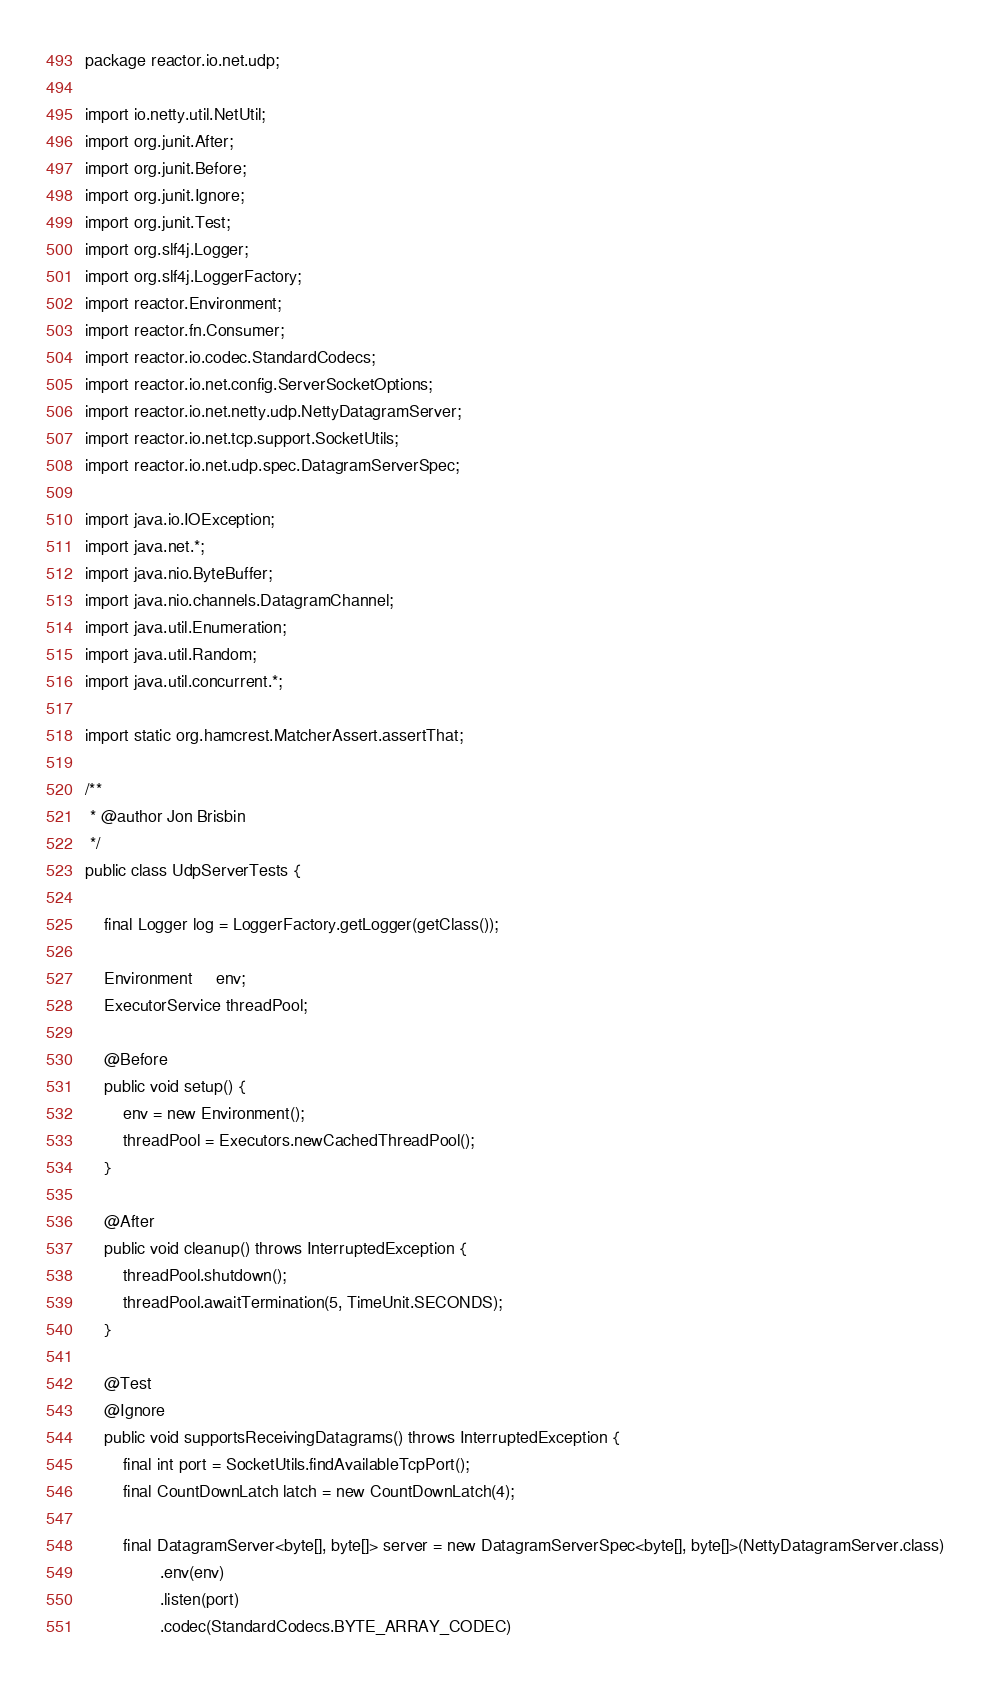Convert code to text. <code><loc_0><loc_0><loc_500><loc_500><_Java_>package reactor.io.net.udp;

import io.netty.util.NetUtil;
import org.junit.After;
import org.junit.Before;
import org.junit.Ignore;
import org.junit.Test;
import org.slf4j.Logger;
import org.slf4j.LoggerFactory;
import reactor.Environment;
import reactor.fn.Consumer;
import reactor.io.codec.StandardCodecs;
import reactor.io.net.config.ServerSocketOptions;
import reactor.io.net.netty.udp.NettyDatagramServer;
import reactor.io.net.tcp.support.SocketUtils;
import reactor.io.net.udp.spec.DatagramServerSpec;

import java.io.IOException;
import java.net.*;
import java.nio.ByteBuffer;
import java.nio.channels.DatagramChannel;
import java.util.Enumeration;
import java.util.Random;
import java.util.concurrent.*;

import static org.hamcrest.MatcherAssert.assertThat;

/**
 * @author Jon Brisbin
 */
public class UdpServerTests {

	final Logger log = LoggerFactory.getLogger(getClass());

	Environment     env;
	ExecutorService threadPool;

	@Before
	public void setup() {
		env = new Environment();
		threadPool = Executors.newCachedThreadPool();
	}

	@After
	public void cleanup() throws InterruptedException {
		threadPool.shutdown();
		threadPool.awaitTermination(5, TimeUnit.SECONDS);
	}

	@Test
	@Ignore
	public void supportsReceivingDatagrams() throws InterruptedException {
		final int port = SocketUtils.findAvailableTcpPort();
		final CountDownLatch latch = new CountDownLatch(4);

		final DatagramServer<byte[], byte[]> server = new DatagramServerSpec<byte[], byte[]>(NettyDatagramServer.class)
				.env(env)
				.listen(port)
				.codec(StandardCodecs.BYTE_ARRAY_CODEC)</code> 